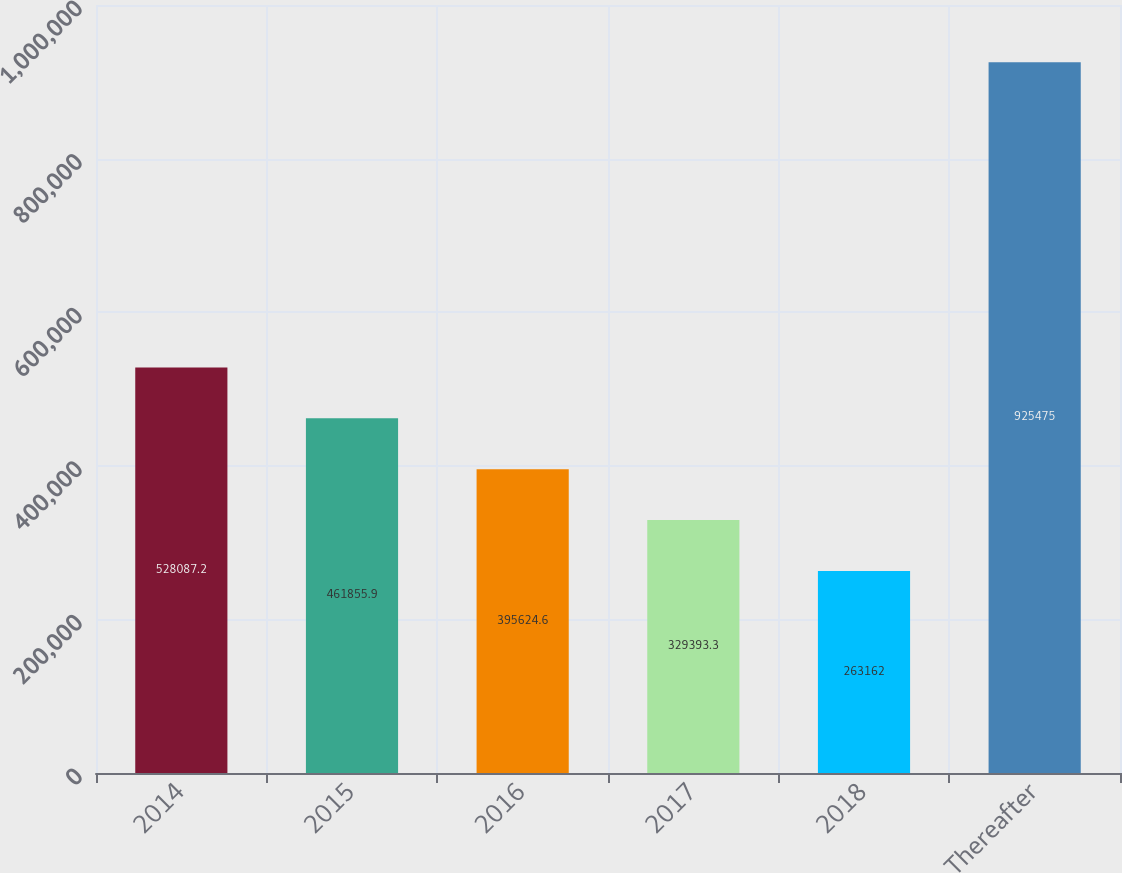<chart> <loc_0><loc_0><loc_500><loc_500><bar_chart><fcel>2014<fcel>2015<fcel>2016<fcel>2017<fcel>2018<fcel>Thereafter<nl><fcel>528087<fcel>461856<fcel>395625<fcel>329393<fcel>263162<fcel>925475<nl></chart> 